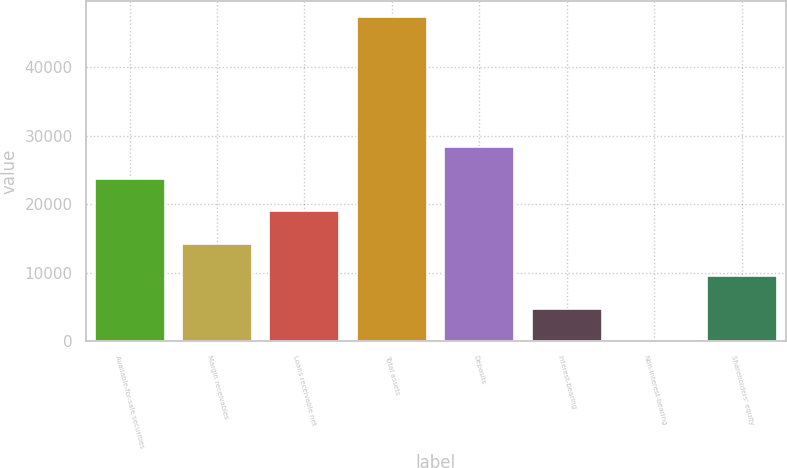<chart> <loc_0><loc_0><loc_500><loc_500><bar_chart><fcel>Available-for-sale securities<fcel>Margin receivables<fcel>Loans receivable net<fcel>Total assets<fcel>Deposits<fcel>Interest-bearing<fcel>Non-interest-bearing<fcel>Shareholders' equity<nl><fcel>23714.7<fcel>14245.9<fcel>18980.3<fcel>47386.7<fcel>28449.1<fcel>4777.1<fcel>42.7<fcel>9511.5<nl></chart> 